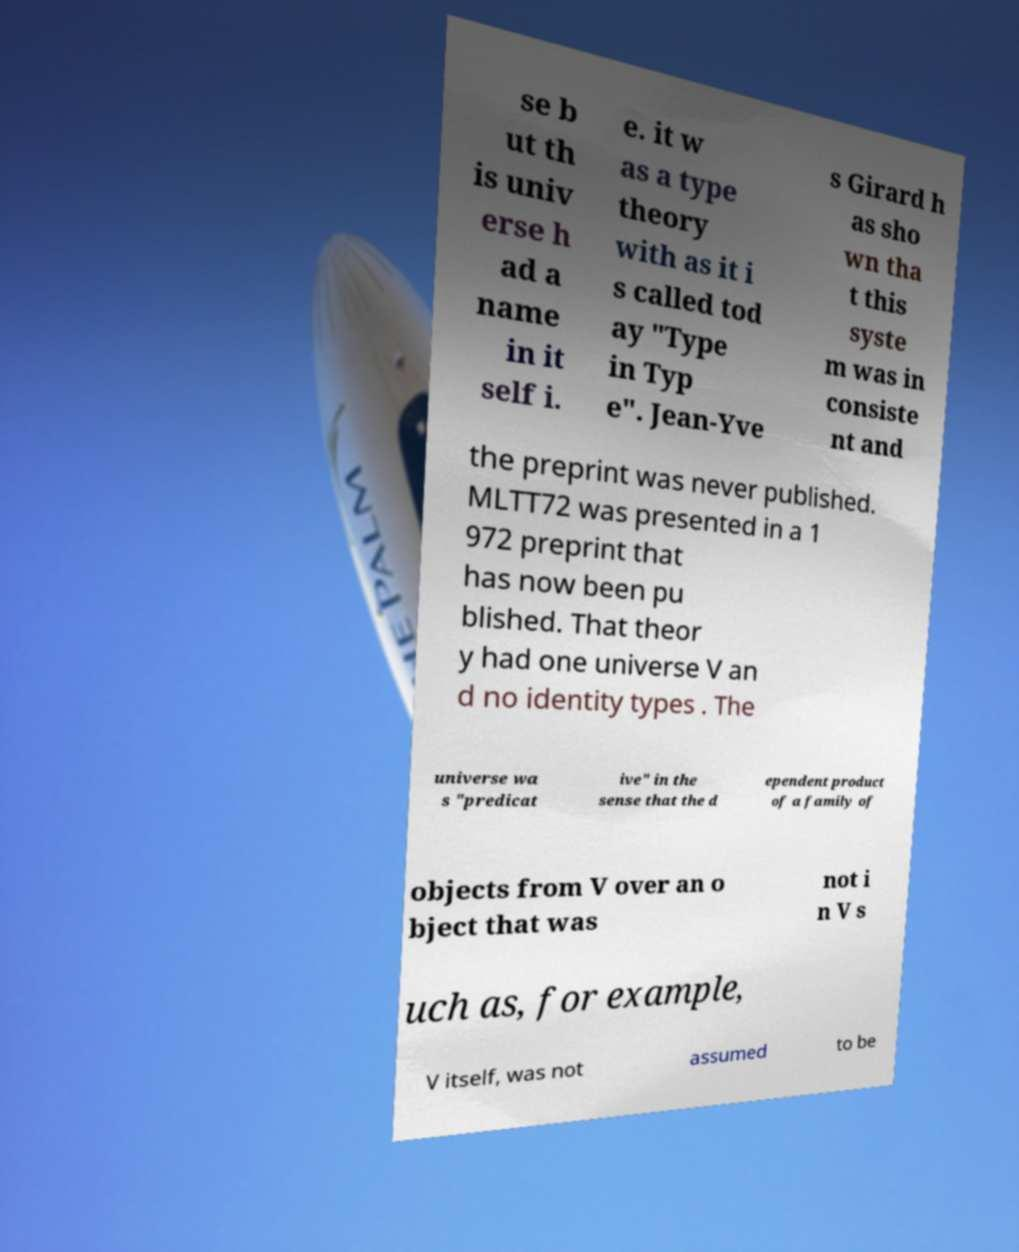Please identify and transcribe the text found in this image. se b ut th is univ erse h ad a name in it self i. e. it w as a type theory with as it i s called tod ay "Type in Typ e". Jean-Yve s Girard h as sho wn tha t this syste m was in consiste nt and the preprint was never published. MLTT72 was presented in a 1 972 preprint that has now been pu blished. That theor y had one universe V an d no identity types . The universe wa s "predicat ive" in the sense that the d ependent product of a family of objects from V over an o bject that was not i n V s uch as, for example, V itself, was not assumed to be 